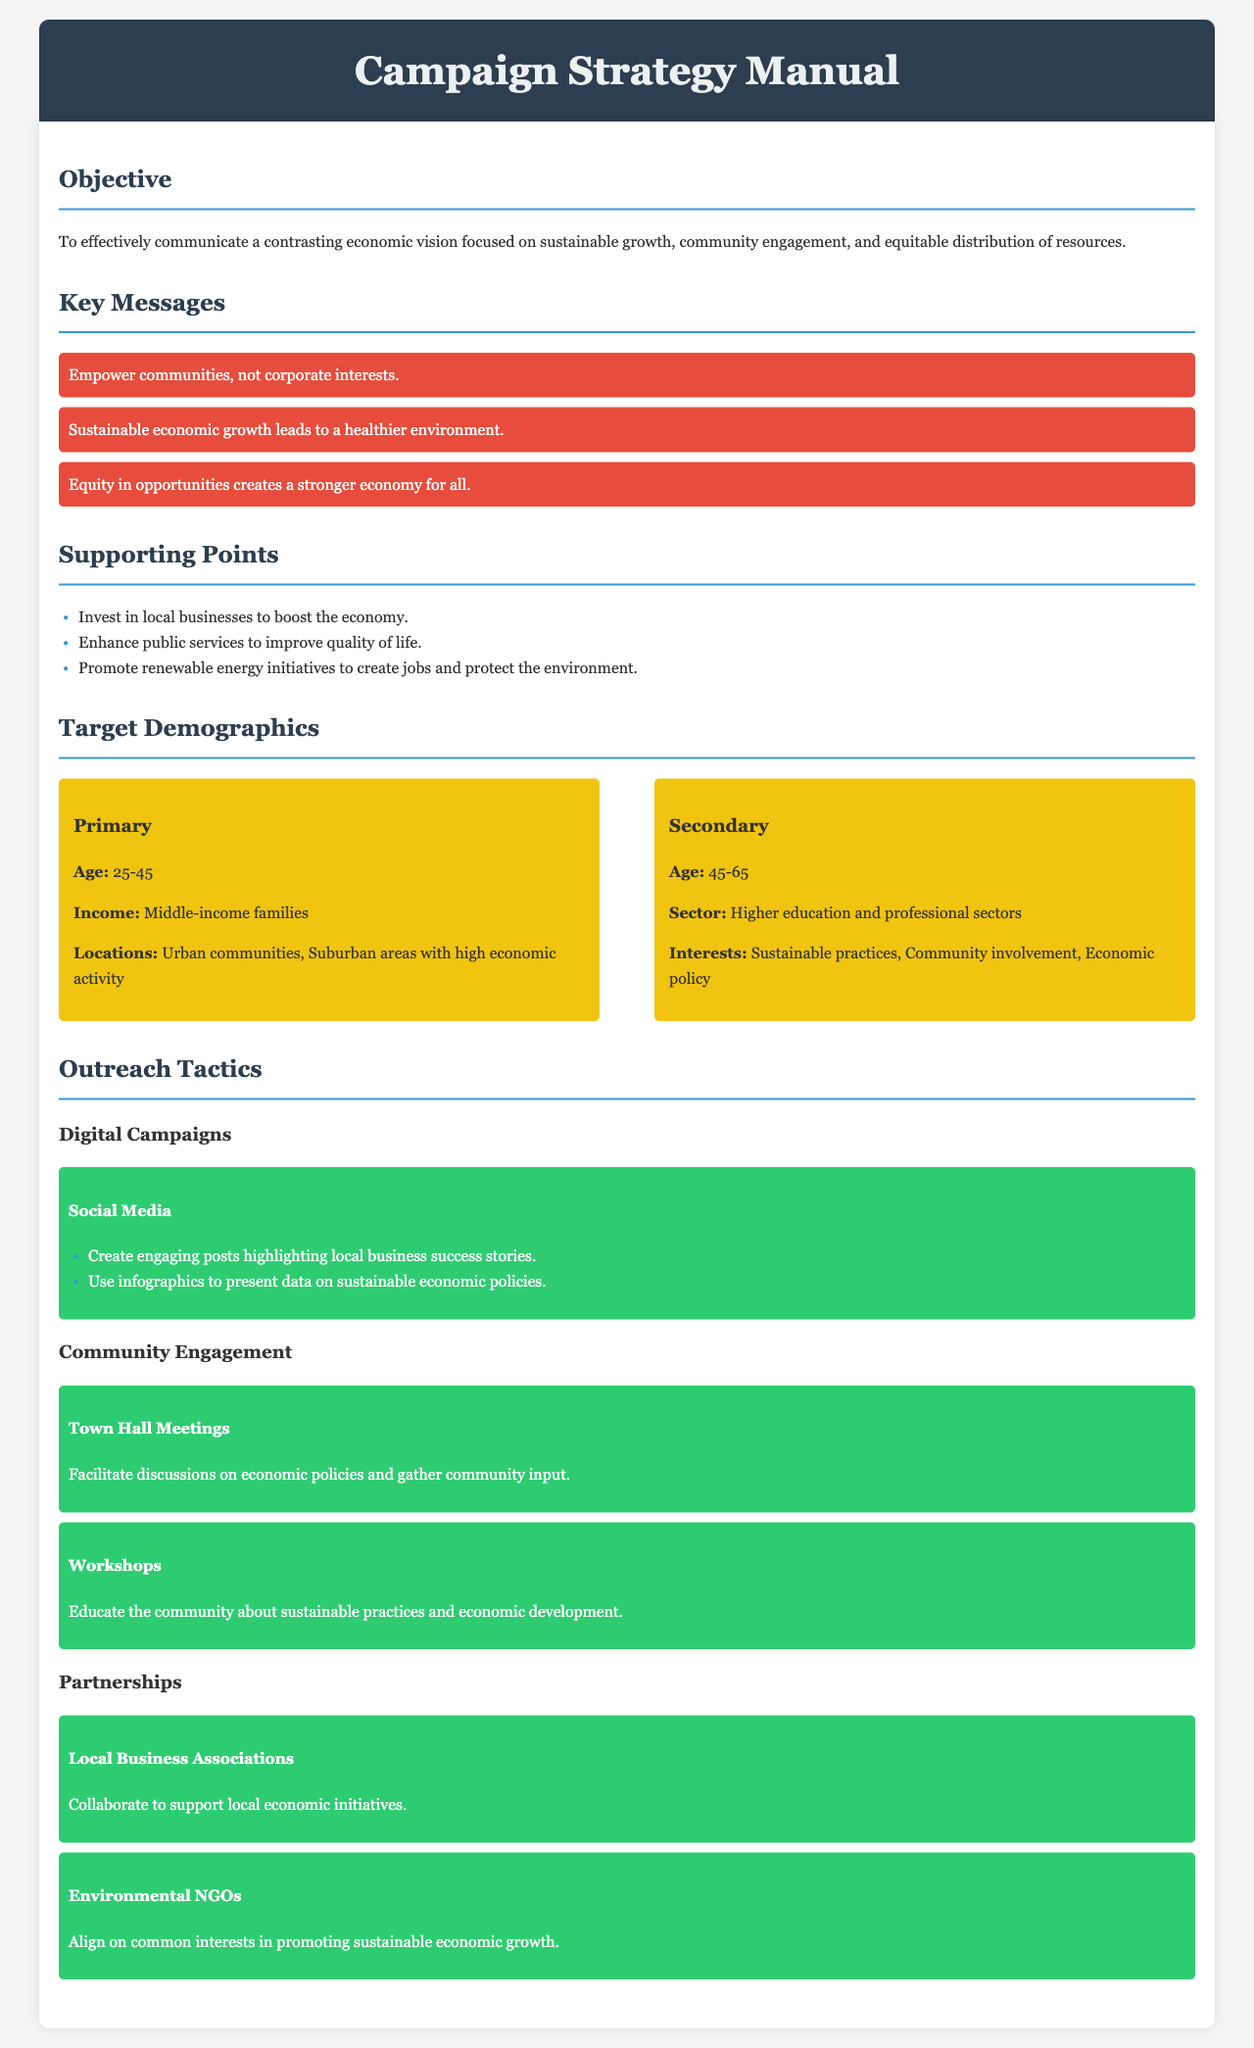What is the primary objective of the campaign? The primary objective is to effectively communicate a contrasting economic vision focused on sustainable growth, community engagement, and equitable distribution of resources.
Answer: To effectively communicate a contrasting economic vision focused on sustainable growth, community engagement, and equitable distribution of resources What is one of the key messages? Key messages are highlighted in the document; one such message emphasizes empowering communities rather than corporate interests.
Answer: Empower communities, not corporate interests What age group is included in the primary target demographic? The primary target demographic includes individuals aged 25-45.
Answer: 25-45 What is one outreach tactic mentioned in the document? The document lists several outreach tactics, including hosting town hall meetings for community engagement.
Answer: Town Hall Meetings What supporting point promotes job creation? The document suggests promoting renewable energy initiatives to create jobs and protect the environment.
Answer: Promote renewable energy initiatives What color is used for the section headers? The section headers utilize a specific color to enhance visibility, which is a shade of blue (#3498db).
Answer: Blue How many target demographics are specified? The document specifies two target demographics: primary and secondary.
Answer: Two What type of organizations should be partnered with for local business initiatives? The document advises partnering with local business associations to support economic initiatives.
Answer: Local Business Associations What is one interest of the secondary target demographic? One interest of the secondary demographic includes sustainable practices, as mentioned in the document.
Answer: Sustainable practices 